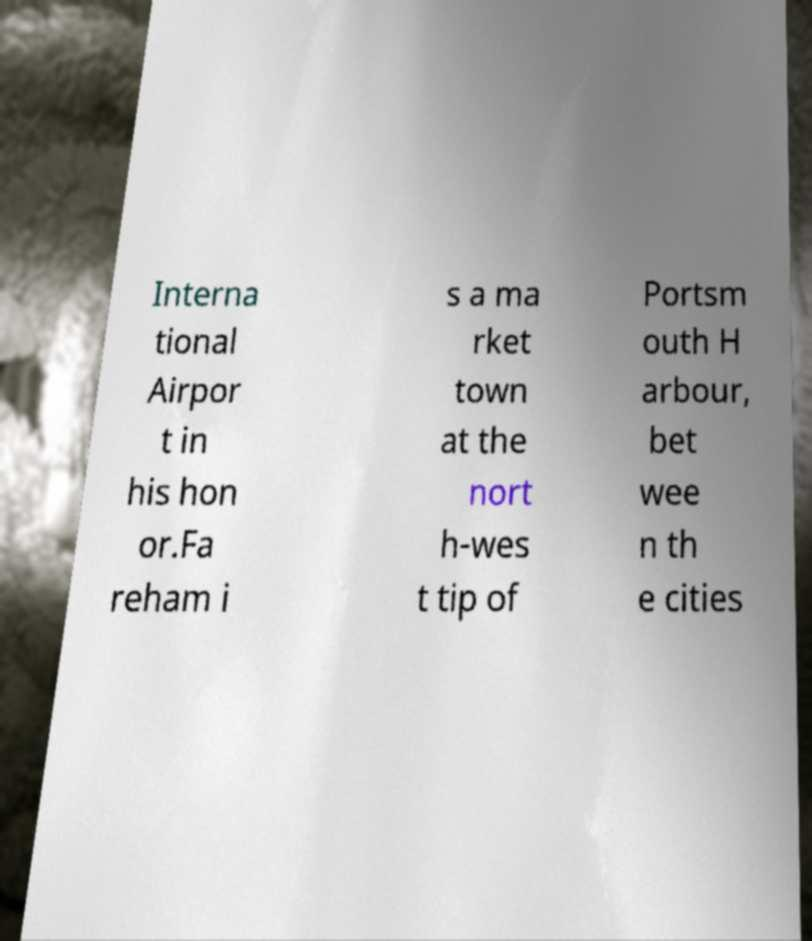I need the written content from this picture converted into text. Can you do that? Interna tional Airpor t in his hon or.Fa reham i s a ma rket town at the nort h-wes t tip of Portsm outh H arbour, bet wee n th e cities 